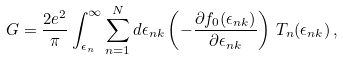Convert formula to latex. <formula><loc_0><loc_0><loc_500><loc_500>G = \frac { 2 e ^ { 2 } } { \pi } \int _ { \epsilon _ { n } } ^ { \infty } \sum _ { n = 1 } ^ { N } d \epsilon _ { n k } \left ( - \frac { \partial f _ { 0 } ( \epsilon _ { n k } ) } { \partial \epsilon _ { n k } } \right ) \, T _ { n } ( \epsilon _ { n k } ) \, ,</formula> 